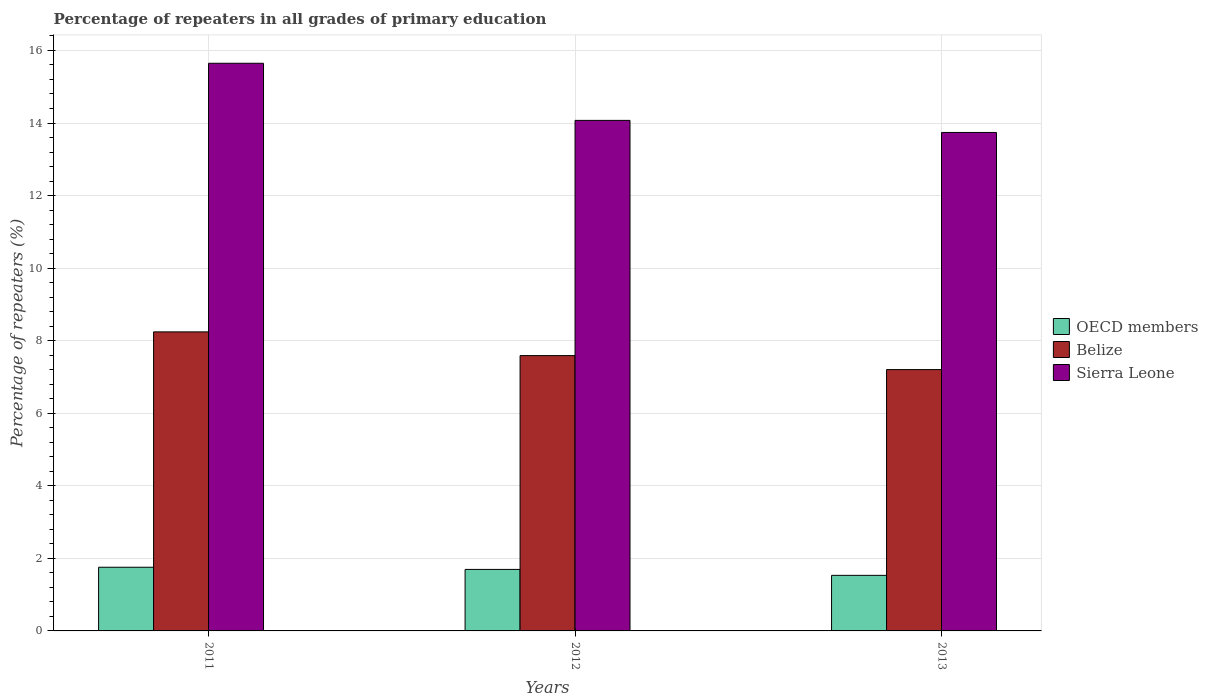How many different coloured bars are there?
Provide a short and direct response. 3. How many groups of bars are there?
Keep it short and to the point. 3. Are the number of bars per tick equal to the number of legend labels?
Your answer should be very brief. Yes. What is the label of the 1st group of bars from the left?
Offer a very short reply. 2011. In how many cases, is the number of bars for a given year not equal to the number of legend labels?
Make the answer very short. 0. What is the percentage of repeaters in Sierra Leone in 2011?
Provide a short and direct response. 15.65. Across all years, what is the maximum percentage of repeaters in OECD members?
Ensure brevity in your answer.  1.76. Across all years, what is the minimum percentage of repeaters in OECD members?
Your response must be concise. 1.53. In which year was the percentage of repeaters in Sierra Leone minimum?
Give a very brief answer. 2013. What is the total percentage of repeaters in Sierra Leone in the graph?
Your answer should be very brief. 43.46. What is the difference between the percentage of repeaters in Sierra Leone in 2012 and that in 2013?
Make the answer very short. 0.33. What is the difference between the percentage of repeaters in Belize in 2011 and the percentage of repeaters in Sierra Leone in 2013?
Your response must be concise. -5.5. What is the average percentage of repeaters in Belize per year?
Provide a succinct answer. 7.68. In the year 2013, what is the difference between the percentage of repeaters in Belize and percentage of repeaters in OECD members?
Your answer should be very brief. 5.67. What is the ratio of the percentage of repeaters in Sierra Leone in 2011 to that in 2013?
Provide a short and direct response. 1.14. Is the percentage of repeaters in Sierra Leone in 2012 less than that in 2013?
Make the answer very short. No. Is the difference between the percentage of repeaters in Belize in 2011 and 2013 greater than the difference between the percentage of repeaters in OECD members in 2011 and 2013?
Your answer should be very brief. Yes. What is the difference between the highest and the second highest percentage of repeaters in Sierra Leone?
Your answer should be very brief. 1.57. What is the difference between the highest and the lowest percentage of repeaters in OECD members?
Ensure brevity in your answer.  0.22. What does the 2nd bar from the left in 2012 represents?
Provide a succinct answer. Belize. What does the 3rd bar from the right in 2012 represents?
Provide a succinct answer. OECD members. How many bars are there?
Your response must be concise. 9. Are the values on the major ticks of Y-axis written in scientific E-notation?
Offer a terse response. No. Does the graph contain any zero values?
Your response must be concise. No. Does the graph contain grids?
Your answer should be compact. Yes. What is the title of the graph?
Offer a very short reply. Percentage of repeaters in all grades of primary education. Does "Belarus" appear as one of the legend labels in the graph?
Provide a short and direct response. No. What is the label or title of the Y-axis?
Keep it short and to the point. Percentage of repeaters (%). What is the Percentage of repeaters (%) of OECD members in 2011?
Your answer should be very brief. 1.76. What is the Percentage of repeaters (%) in Belize in 2011?
Offer a terse response. 8.24. What is the Percentage of repeaters (%) in Sierra Leone in 2011?
Make the answer very short. 15.65. What is the Percentage of repeaters (%) in OECD members in 2012?
Your answer should be compact. 1.7. What is the Percentage of repeaters (%) of Belize in 2012?
Offer a very short reply. 7.59. What is the Percentage of repeaters (%) in Sierra Leone in 2012?
Keep it short and to the point. 14.07. What is the Percentage of repeaters (%) of OECD members in 2013?
Offer a terse response. 1.53. What is the Percentage of repeaters (%) in Belize in 2013?
Provide a succinct answer. 7.2. What is the Percentage of repeaters (%) in Sierra Leone in 2013?
Ensure brevity in your answer.  13.74. Across all years, what is the maximum Percentage of repeaters (%) in OECD members?
Make the answer very short. 1.76. Across all years, what is the maximum Percentage of repeaters (%) in Belize?
Keep it short and to the point. 8.24. Across all years, what is the maximum Percentage of repeaters (%) in Sierra Leone?
Provide a short and direct response. 15.65. Across all years, what is the minimum Percentage of repeaters (%) of OECD members?
Keep it short and to the point. 1.53. Across all years, what is the minimum Percentage of repeaters (%) in Belize?
Provide a succinct answer. 7.2. Across all years, what is the minimum Percentage of repeaters (%) in Sierra Leone?
Your answer should be compact. 13.74. What is the total Percentage of repeaters (%) in OECD members in the graph?
Your response must be concise. 4.98. What is the total Percentage of repeaters (%) of Belize in the graph?
Offer a terse response. 23.03. What is the total Percentage of repeaters (%) in Sierra Leone in the graph?
Your answer should be very brief. 43.46. What is the difference between the Percentage of repeaters (%) of OECD members in 2011 and that in 2012?
Your answer should be compact. 0.06. What is the difference between the Percentage of repeaters (%) of Belize in 2011 and that in 2012?
Give a very brief answer. 0.65. What is the difference between the Percentage of repeaters (%) of Sierra Leone in 2011 and that in 2012?
Give a very brief answer. 1.57. What is the difference between the Percentage of repeaters (%) in OECD members in 2011 and that in 2013?
Provide a succinct answer. 0.22. What is the difference between the Percentage of repeaters (%) of Belize in 2011 and that in 2013?
Your answer should be compact. 1.04. What is the difference between the Percentage of repeaters (%) in Sierra Leone in 2011 and that in 2013?
Provide a succinct answer. 1.91. What is the difference between the Percentage of repeaters (%) of OECD members in 2012 and that in 2013?
Ensure brevity in your answer.  0.16. What is the difference between the Percentage of repeaters (%) in Belize in 2012 and that in 2013?
Provide a succinct answer. 0.39. What is the difference between the Percentage of repeaters (%) of Sierra Leone in 2012 and that in 2013?
Your answer should be very brief. 0.33. What is the difference between the Percentage of repeaters (%) of OECD members in 2011 and the Percentage of repeaters (%) of Belize in 2012?
Offer a very short reply. -5.83. What is the difference between the Percentage of repeaters (%) of OECD members in 2011 and the Percentage of repeaters (%) of Sierra Leone in 2012?
Your answer should be compact. -12.32. What is the difference between the Percentage of repeaters (%) in Belize in 2011 and the Percentage of repeaters (%) in Sierra Leone in 2012?
Give a very brief answer. -5.83. What is the difference between the Percentage of repeaters (%) in OECD members in 2011 and the Percentage of repeaters (%) in Belize in 2013?
Ensure brevity in your answer.  -5.45. What is the difference between the Percentage of repeaters (%) of OECD members in 2011 and the Percentage of repeaters (%) of Sierra Leone in 2013?
Offer a terse response. -11.98. What is the difference between the Percentage of repeaters (%) in Belize in 2011 and the Percentage of repeaters (%) in Sierra Leone in 2013?
Ensure brevity in your answer.  -5.5. What is the difference between the Percentage of repeaters (%) of OECD members in 2012 and the Percentage of repeaters (%) of Belize in 2013?
Provide a short and direct response. -5.51. What is the difference between the Percentage of repeaters (%) of OECD members in 2012 and the Percentage of repeaters (%) of Sierra Leone in 2013?
Keep it short and to the point. -12.04. What is the difference between the Percentage of repeaters (%) of Belize in 2012 and the Percentage of repeaters (%) of Sierra Leone in 2013?
Give a very brief answer. -6.15. What is the average Percentage of repeaters (%) in OECD members per year?
Provide a succinct answer. 1.66. What is the average Percentage of repeaters (%) in Belize per year?
Ensure brevity in your answer.  7.68. What is the average Percentage of repeaters (%) in Sierra Leone per year?
Provide a succinct answer. 14.49. In the year 2011, what is the difference between the Percentage of repeaters (%) in OECD members and Percentage of repeaters (%) in Belize?
Keep it short and to the point. -6.49. In the year 2011, what is the difference between the Percentage of repeaters (%) of OECD members and Percentage of repeaters (%) of Sierra Leone?
Your answer should be compact. -13.89. In the year 2011, what is the difference between the Percentage of repeaters (%) in Belize and Percentage of repeaters (%) in Sierra Leone?
Keep it short and to the point. -7.4. In the year 2012, what is the difference between the Percentage of repeaters (%) of OECD members and Percentage of repeaters (%) of Belize?
Give a very brief answer. -5.89. In the year 2012, what is the difference between the Percentage of repeaters (%) in OECD members and Percentage of repeaters (%) in Sierra Leone?
Provide a succinct answer. -12.38. In the year 2012, what is the difference between the Percentage of repeaters (%) of Belize and Percentage of repeaters (%) of Sierra Leone?
Give a very brief answer. -6.48. In the year 2013, what is the difference between the Percentage of repeaters (%) of OECD members and Percentage of repeaters (%) of Belize?
Give a very brief answer. -5.67. In the year 2013, what is the difference between the Percentage of repeaters (%) of OECD members and Percentage of repeaters (%) of Sierra Leone?
Your answer should be very brief. -12.21. In the year 2013, what is the difference between the Percentage of repeaters (%) in Belize and Percentage of repeaters (%) in Sierra Leone?
Your answer should be compact. -6.54. What is the ratio of the Percentage of repeaters (%) in OECD members in 2011 to that in 2012?
Keep it short and to the point. 1.04. What is the ratio of the Percentage of repeaters (%) of Belize in 2011 to that in 2012?
Give a very brief answer. 1.09. What is the ratio of the Percentage of repeaters (%) of Sierra Leone in 2011 to that in 2012?
Keep it short and to the point. 1.11. What is the ratio of the Percentage of repeaters (%) in OECD members in 2011 to that in 2013?
Ensure brevity in your answer.  1.15. What is the ratio of the Percentage of repeaters (%) of Belize in 2011 to that in 2013?
Your answer should be very brief. 1.14. What is the ratio of the Percentage of repeaters (%) of Sierra Leone in 2011 to that in 2013?
Your response must be concise. 1.14. What is the ratio of the Percentage of repeaters (%) of OECD members in 2012 to that in 2013?
Your answer should be very brief. 1.11. What is the ratio of the Percentage of repeaters (%) of Belize in 2012 to that in 2013?
Keep it short and to the point. 1.05. What is the ratio of the Percentage of repeaters (%) in Sierra Leone in 2012 to that in 2013?
Provide a short and direct response. 1.02. What is the difference between the highest and the second highest Percentage of repeaters (%) in OECD members?
Give a very brief answer. 0.06. What is the difference between the highest and the second highest Percentage of repeaters (%) in Belize?
Your response must be concise. 0.65. What is the difference between the highest and the second highest Percentage of repeaters (%) of Sierra Leone?
Keep it short and to the point. 1.57. What is the difference between the highest and the lowest Percentage of repeaters (%) in OECD members?
Offer a terse response. 0.22. What is the difference between the highest and the lowest Percentage of repeaters (%) in Belize?
Provide a succinct answer. 1.04. What is the difference between the highest and the lowest Percentage of repeaters (%) of Sierra Leone?
Your answer should be compact. 1.91. 